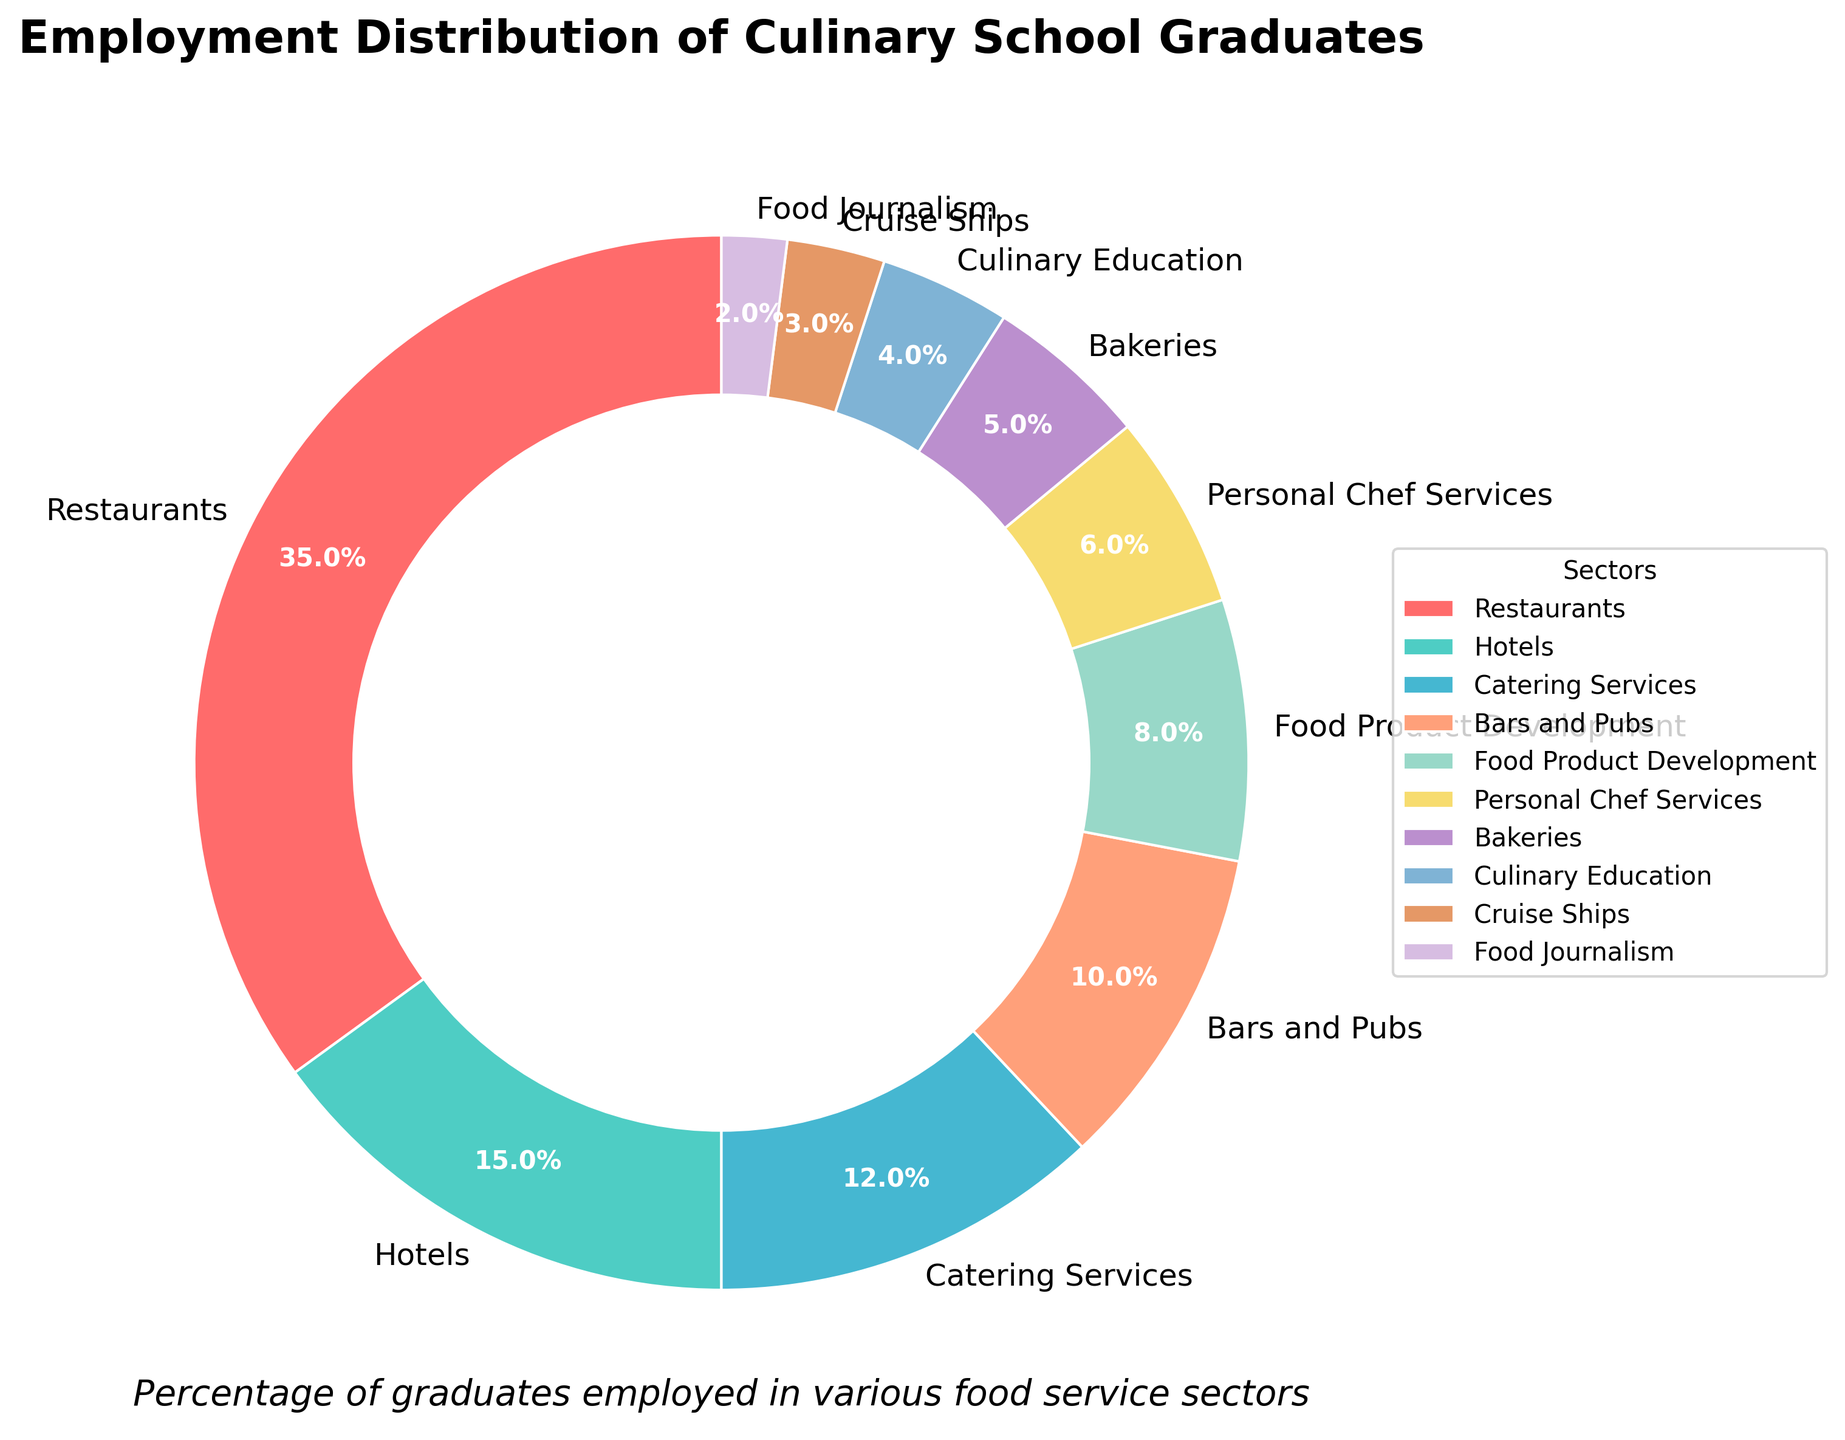What percentage of culinary school graduates are employed in Restaurants and Catering Services combined? First, identify the percentage for Restaurants (35%) and Catering Services (12%) from the figure. Then sum them up: 35 + 12 = 47.
Answer: 47 Which sector employs fewer culinary school graduates: Bars and Pubs or Bakeries? Check the percentage for Bars and Pubs (10%) and for Bakeries (5%) from the figure. Compare the two: 5 < 10, so Bakeries employ fewer graduates.
Answer: Bakeries What is the difference in employment percentage between Hotels and Cruise Ships? Identify the percentages for Hotels (15%) and Cruise Ships (3%) from the figure. Subtract the smaller percentage from the larger: 15 - 3 = 12.
Answer: 12 Which sectors have an equal number of culinary school graduates? By examining the pie chart, the sectors with equal percentages are not immediately obvious for further comparison. No sectors share the same percentage directly.
Answer: None What is the combined percentage of graduates working in Food Product Development, Personal Chef Services, and Food Journalism? Identify the percentages for Food Product Development (8%), Personal Chef Services (6%), and Food Journalism (2%) from the figure. Sum them up: 8 + 6 + 2 = 16.
Answer: 16 Which sector employs the largest percentage of culinary school graduates? By observing the figure, Restaurants hold the highest percentage of graduates, which is 35%.
Answer: Restaurants Are there more graduates working in Culinary Education or Personal Chef Services? Check the percentages for Culinary Education (4%) and Personal Chef Services (6%) from the figure. Compare the two: 6 > 4, so more graduates work in Personal Chef Services.
Answer: Personal Chef Services Which sector employs the third largest percentage of graduates? From the figure, the ranks are: 1. Restaurants (35%), 2. Hotels (15%), 3. Catering Services (12%). Therefore, Catering Services employ the third largest percentage.
Answer: Catering Services What is the total percentage of graduates working either in Food Product Development or Cruise Ships? From the pie chart, the percentage for Food Product Development is 8% and for Cruise Ships is 3%. Sum them up: 8 + 3 = 11.
Answer: 11 